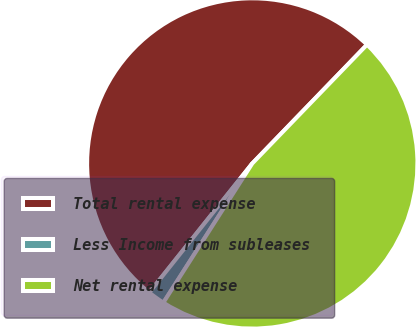<chart> <loc_0><loc_0><loc_500><loc_500><pie_chart><fcel>Total rental expense<fcel>Less Income from subleases<fcel>Net rental expense<nl><fcel>51.51%<fcel>1.67%<fcel>46.82%<nl></chart> 